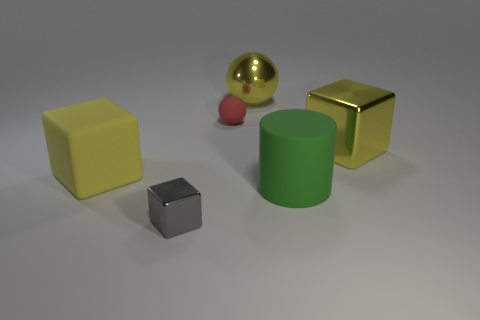Is the tiny red object the same shape as the tiny gray metal thing?
Your response must be concise. No. What is the size of the ball that is the same color as the rubber block?
Your answer should be very brief. Large. There is a gray metallic cube in front of the small ball; how many big matte blocks are left of it?
Your response must be concise. 1. How many metal things are both in front of the yellow metal ball and to the right of the red sphere?
Provide a succinct answer. 1. How many things are either green matte objects or shiny things that are behind the tiny metallic block?
Provide a succinct answer. 3. There is a block that is the same material as the green thing; what is its size?
Ensure brevity in your answer.  Large. What is the shape of the tiny thing in front of the cylinder to the right of the large yellow shiny ball?
Keep it short and to the point. Cube. What number of red objects are either big rubber things or small things?
Your answer should be compact. 1. Is there a large matte object to the left of the yellow shiny object right of the big shiny thing that is behind the small red rubber thing?
Give a very brief answer. Yes. What is the shape of the large metallic thing that is the same color as the large metallic block?
Ensure brevity in your answer.  Sphere. 